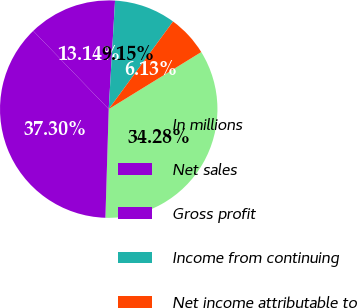Convert chart. <chart><loc_0><loc_0><loc_500><loc_500><pie_chart><fcel>In millions<fcel>Net sales<fcel>Gross profit<fcel>Income from continuing<fcel>Net income attributable to<nl><fcel>34.28%<fcel>37.3%<fcel>13.14%<fcel>9.15%<fcel>6.13%<nl></chart> 